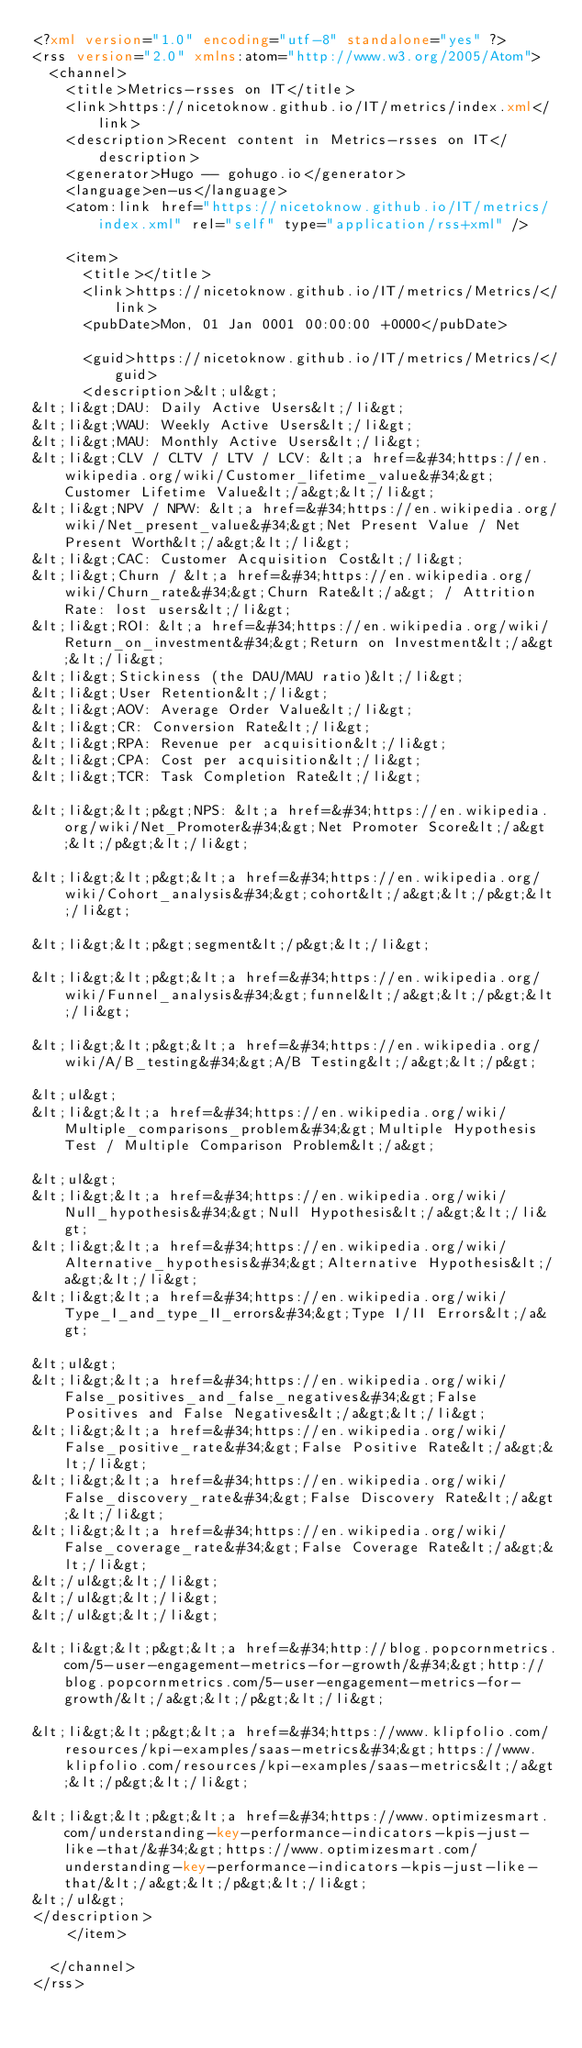Convert code to text. <code><loc_0><loc_0><loc_500><loc_500><_XML_><?xml version="1.0" encoding="utf-8" standalone="yes" ?>
<rss version="2.0" xmlns:atom="http://www.w3.org/2005/Atom">
  <channel>
    <title>Metrics-rsses on IT</title>
    <link>https://nicetoknow.github.io/IT/metrics/index.xml</link>
    <description>Recent content in Metrics-rsses on IT</description>
    <generator>Hugo -- gohugo.io</generator>
    <language>en-us</language>
    <atom:link href="https://nicetoknow.github.io/IT/metrics/index.xml" rel="self" type="application/rss+xml" />
    
    <item>
      <title></title>
      <link>https://nicetoknow.github.io/IT/metrics/Metrics/</link>
      <pubDate>Mon, 01 Jan 0001 00:00:00 +0000</pubDate>
      
      <guid>https://nicetoknow.github.io/IT/metrics/Metrics/</guid>
      <description>&lt;ul&gt;
&lt;li&gt;DAU: Daily Active Users&lt;/li&gt;
&lt;li&gt;WAU: Weekly Active Users&lt;/li&gt;
&lt;li&gt;MAU: Monthly Active Users&lt;/li&gt;
&lt;li&gt;CLV / CLTV / LTV / LCV: &lt;a href=&#34;https://en.wikipedia.org/wiki/Customer_lifetime_value&#34;&gt;Customer Lifetime Value&lt;/a&gt;&lt;/li&gt;
&lt;li&gt;NPV / NPW: &lt;a href=&#34;https://en.wikipedia.org/wiki/Net_present_value&#34;&gt;Net Present Value / Net Present Worth&lt;/a&gt;&lt;/li&gt;
&lt;li&gt;CAC: Customer Acquisition Cost&lt;/li&gt;
&lt;li&gt;Churn / &lt;a href=&#34;https://en.wikipedia.org/wiki/Churn_rate&#34;&gt;Churn Rate&lt;/a&gt; / Attrition Rate: lost users&lt;/li&gt;
&lt;li&gt;ROI: &lt;a href=&#34;https://en.wikipedia.org/wiki/Return_on_investment&#34;&gt;Return on Investment&lt;/a&gt;&lt;/li&gt;
&lt;li&gt;Stickiness (the DAU/MAU ratio)&lt;/li&gt;
&lt;li&gt;User Retention&lt;/li&gt;
&lt;li&gt;AOV: Average Order Value&lt;/li&gt;
&lt;li&gt;CR: Conversion Rate&lt;/li&gt;
&lt;li&gt;RPA: Revenue per acquisition&lt;/li&gt;
&lt;li&gt;CPA: Cost per acquisition&lt;/li&gt;
&lt;li&gt;TCR: Task Completion Rate&lt;/li&gt;

&lt;li&gt;&lt;p&gt;NPS: &lt;a href=&#34;https://en.wikipedia.org/wiki/Net_Promoter&#34;&gt;Net Promoter Score&lt;/a&gt;&lt;/p&gt;&lt;/li&gt;

&lt;li&gt;&lt;p&gt;&lt;a href=&#34;https://en.wikipedia.org/wiki/Cohort_analysis&#34;&gt;cohort&lt;/a&gt;&lt;/p&gt;&lt;/li&gt;

&lt;li&gt;&lt;p&gt;segment&lt;/p&gt;&lt;/li&gt;

&lt;li&gt;&lt;p&gt;&lt;a href=&#34;https://en.wikipedia.org/wiki/Funnel_analysis&#34;&gt;funnel&lt;/a&gt;&lt;/p&gt;&lt;/li&gt;

&lt;li&gt;&lt;p&gt;&lt;a href=&#34;https://en.wikipedia.org/wiki/A/B_testing&#34;&gt;A/B Testing&lt;/a&gt;&lt;/p&gt;

&lt;ul&gt;
&lt;li&gt;&lt;a href=&#34;https://en.wikipedia.org/wiki/Multiple_comparisons_problem&#34;&gt;Multiple Hypothesis Test / Multiple Comparison Problem&lt;/a&gt;

&lt;ul&gt;
&lt;li&gt;&lt;a href=&#34;https://en.wikipedia.org/wiki/Null_hypothesis&#34;&gt;Null Hypothesis&lt;/a&gt;&lt;/li&gt;
&lt;li&gt;&lt;a href=&#34;https://en.wikipedia.org/wiki/Alternative_hypothesis&#34;&gt;Alternative Hypothesis&lt;/a&gt;&lt;/li&gt;
&lt;li&gt;&lt;a href=&#34;https://en.wikipedia.org/wiki/Type_I_and_type_II_errors&#34;&gt;Type I/II Errors&lt;/a&gt;

&lt;ul&gt;
&lt;li&gt;&lt;a href=&#34;https://en.wikipedia.org/wiki/False_positives_and_false_negatives&#34;&gt;False Positives and False Negatives&lt;/a&gt;&lt;/li&gt;
&lt;li&gt;&lt;a href=&#34;https://en.wikipedia.org/wiki/False_positive_rate&#34;&gt;False Positive Rate&lt;/a&gt;&lt;/li&gt;
&lt;li&gt;&lt;a href=&#34;https://en.wikipedia.org/wiki/False_discovery_rate&#34;&gt;False Discovery Rate&lt;/a&gt;&lt;/li&gt;
&lt;li&gt;&lt;a href=&#34;https://en.wikipedia.org/wiki/False_coverage_rate&#34;&gt;False Coverage Rate&lt;/a&gt;&lt;/li&gt;
&lt;/ul&gt;&lt;/li&gt;
&lt;/ul&gt;&lt;/li&gt;
&lt;/ul&gt;&lt;/li&gt;

&lt;li&gt;&lt;p&gt;&lt;a href=&#34;http://blog.popcornmetrics.com/5-user-engagement-metrics-for-growth/&#34;&gt;http://blog.popcornmetrics.com/5-user-engagement-metrics-for-growth/&lt;/a&gt;&lt;/p&gt;&lt;/li&gt;

&lt;li&gt;&lt;p&gt;&lt;a href=&#34;https://www.klipfolio.com/resources/kpi-examples/saas-metrics&#34;&gt;https://www.klipfolio.com/resources/kpi-examples/saas-metrics&lt;/a&gt;&lt;/p&gt;&lt;/li&gt;

&lt;li&gt;&lt;p&gt;&lt;a href=&#34;https://www.optimizesmart.com/understanding-key-performance-indicators-kpis-just-like-that/&#34;&gt;https://www.optimizesmart.com/understanding-key-performance-indicators-kpis-just-like-that/&lt;/a&gt;&lt;/p&gt;&lt;/li&gt;
&lt;/ul&gt;
</description>
    </item>
    
  </channel>
</rss></code> 